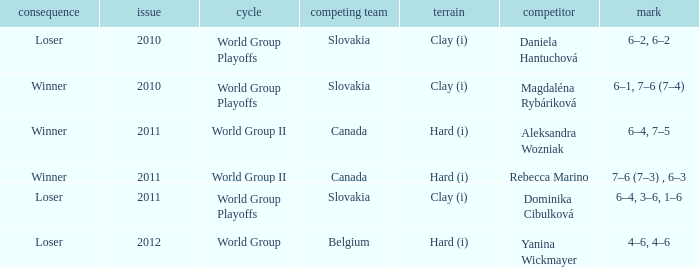What was the outcome of the game when the opponent was Magdaléna Rybáriková? Winner. 